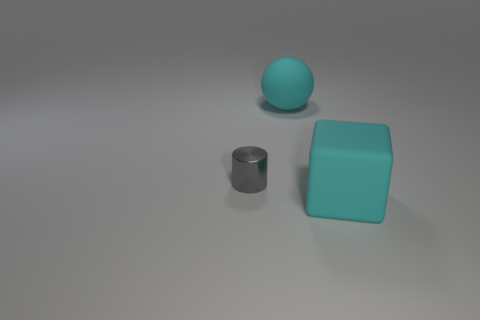What material is the large object behind the cyan thing that is in front of the sphere that is behind the big cyan block?
Give a very brief answer. Rubber. What number of metallic objects are large balls or tiny gray things?
Give a very brief answer. 1. How many small cylinders are there?
Provide a succinct answer. 1. Is the block the same size as the sphere?
Provide a short and direct response. Yes. There is a large matte object that is the same color as the sphere; what is its shape?
Ensure brevity in your answer.  Cube. Do the cyan matte block and the cyan thing behind the large cube have the same size?
Make the answer very short. Yes. What color is the object that is in front of the cyan matte ball and behind the large matte cube?
Your answer should be compact. Gray. Is the number of tiny objects that are in front of the cyan matte ball greater than the number of metallic objects on the right side of the cyan matte block?
Offer a terse response. Yes. What size is the cyan thing that is the same material as the ball?
Make the answer very short. Large. What number of matte blocks are left of the big cyan object to the left of the big block?
Ensure brevity in your answer.  0. 